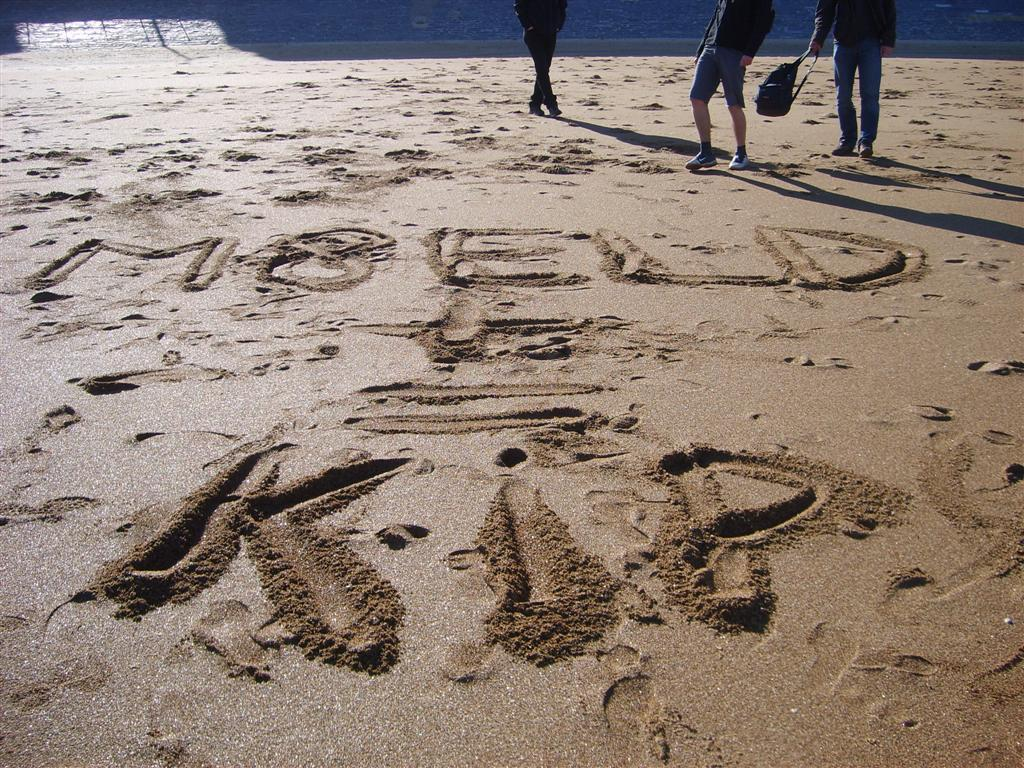What is the main feature of the floor in the image? The floor in the image is muddy and located in the center. Can you describe the people in the image? The people are located at the top side of the image. What type of ornament is hanging from the ceiling in the image? There is no ornament hanging from the ceiling in the image; it only features a muddy floor and people at the top side. How many fish can be seen swimming in the muddy floor? There are no fish present in the image; it only features a muddy floor and people at the top side. 